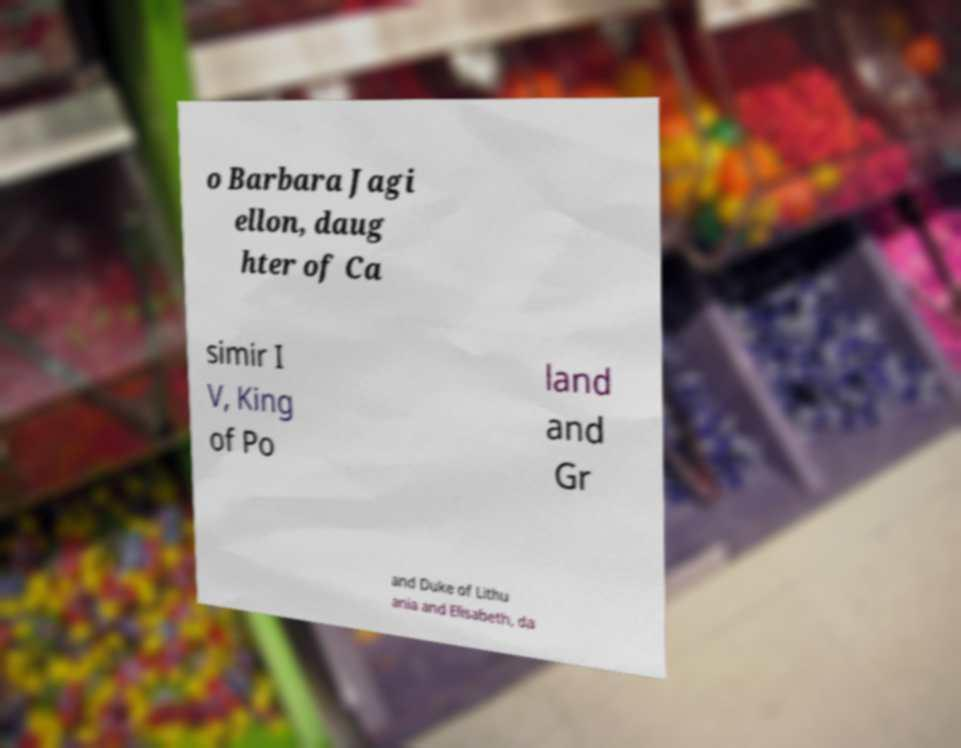What messages or text are displayed in this image? I need them in a readable, typed format. o Barbara Jagi ellon, daug hter of Ca simir I V, King of Po land and Gr and Duke of Lithu ania and Elisabeth, da 